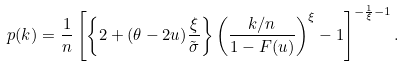<formula> <loc_0><loc_0><loc_500><loc_500>p ( k ) = \frac { 1 } { n } \left [ \left \{ 2 + ( \theta - 2 u ) \frac { \xi } { \tilde { \sigma } } \right \} \left ( \frac { k / n } { 1 - F ( u ) } \right ) ^ { \xi } - 1 \right ] ^ { - \frac { 1 } { \xi } - 1 } .</formula> 